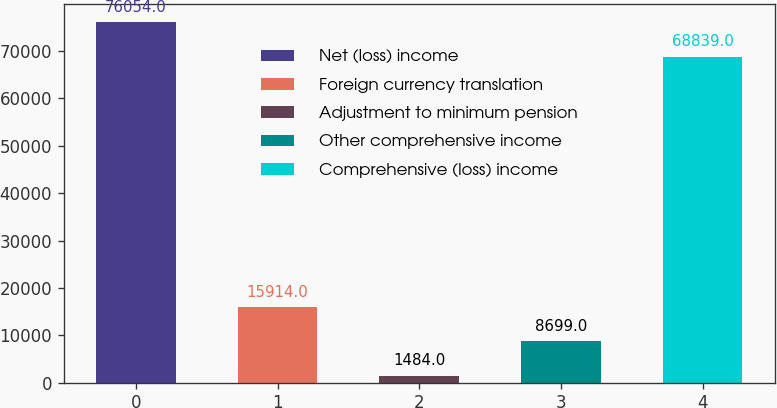Convert chart to OTSL. <chart><loc_0><loc_0><loc_500><loc_500><bar_chart><fcel>Net (loss) income<fcel>Foreign currency translation<fcel>Adjustment to minimum pension<fcel>Other comprehensive income<fcel>Comprehensive (loss) income<nl><fcel>76054<fcel>15914<fcel>1484<fcel>8699<fcel>68839<nl></chart> 